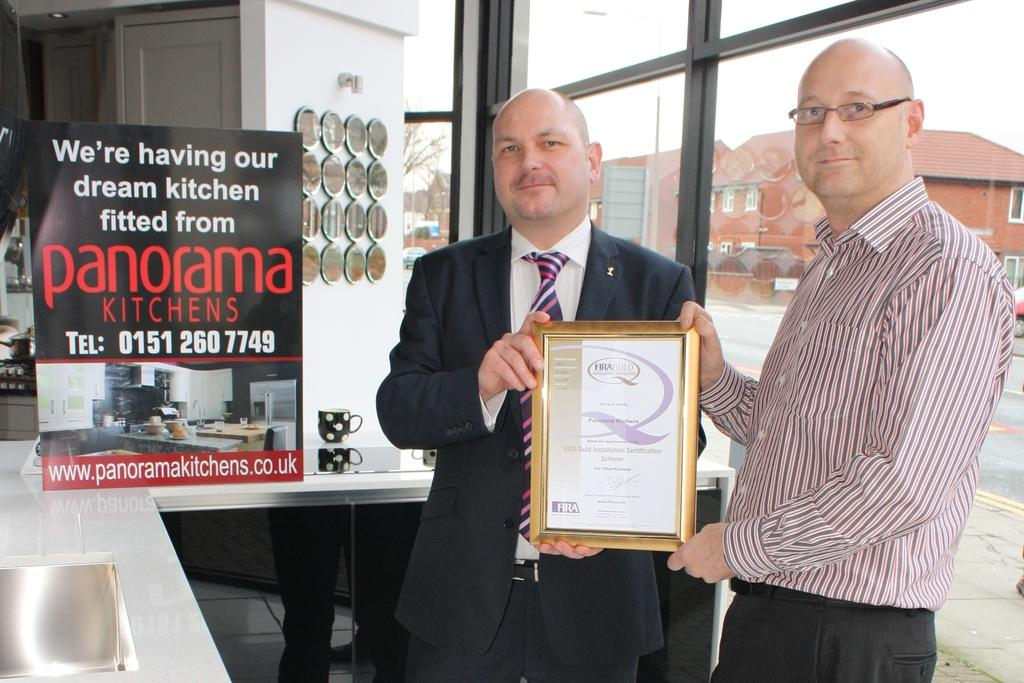<image>
Render a clear and concise summary of the photo. Two men are holding up a framed certificate by a sign that says panorama kitchens. 